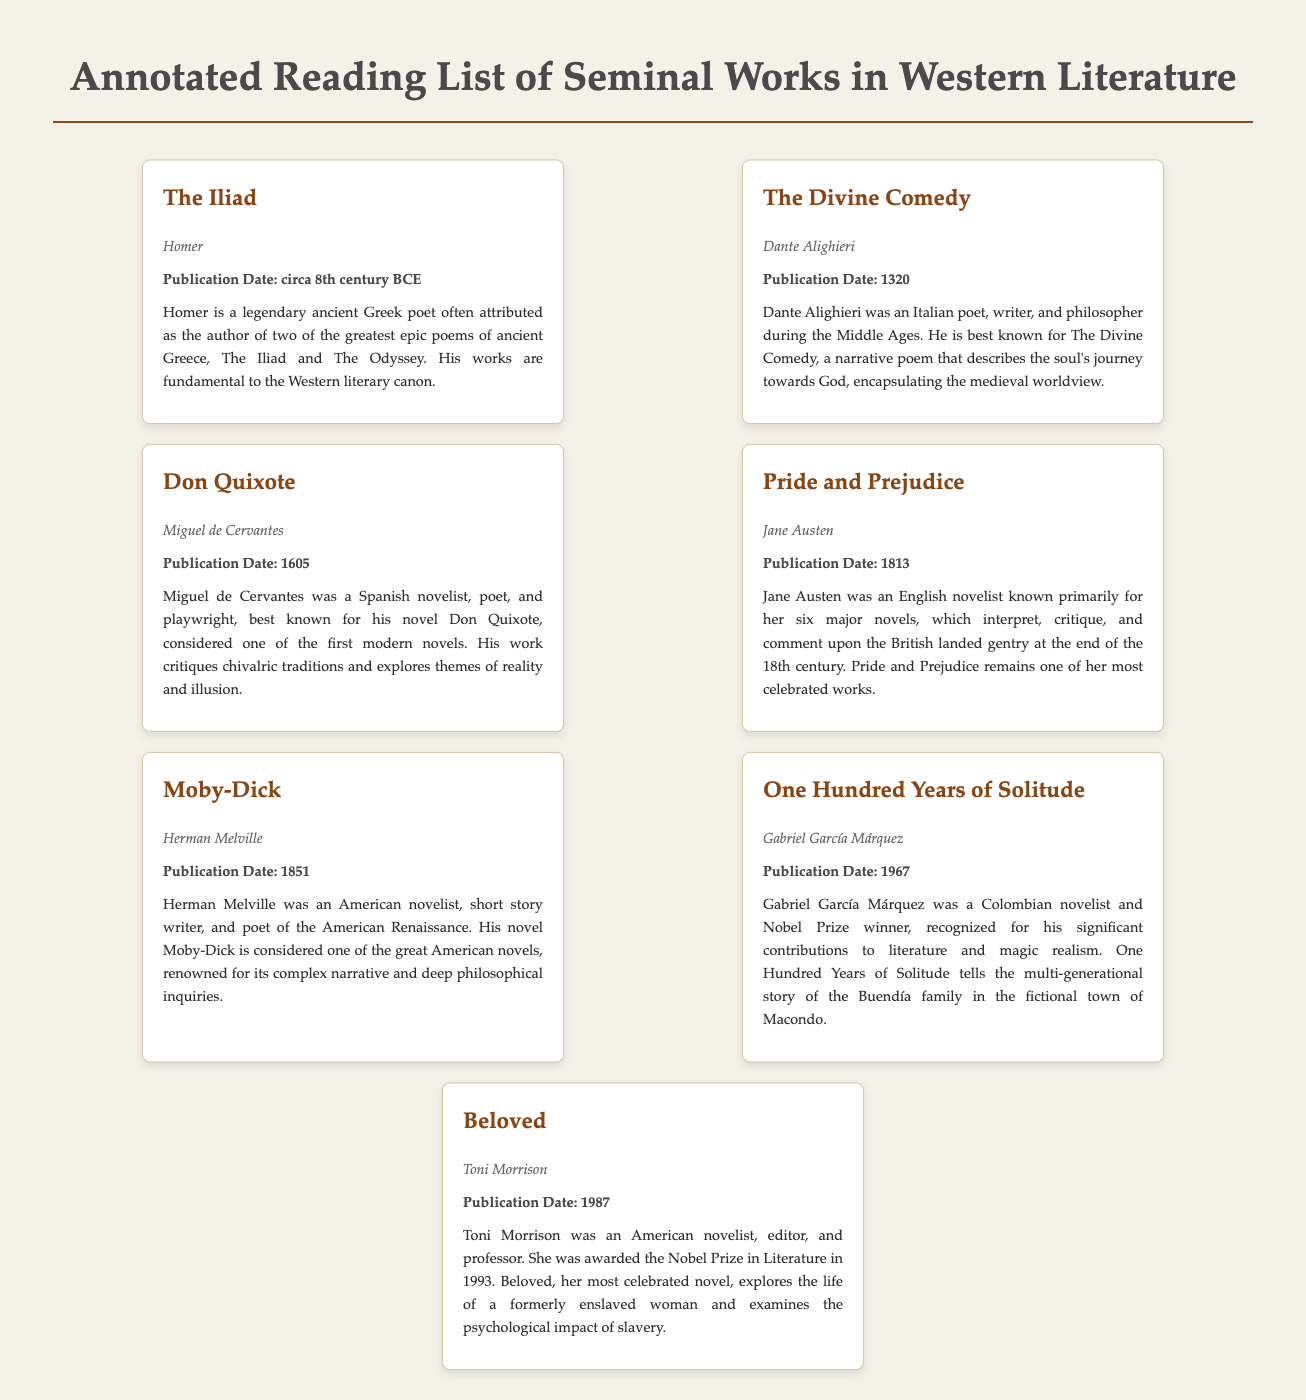What is the title of the first book listed? The first book listed in the document is presented as "The Iliad".
Answer: The Iliad Who is the author of "Don Quixote"? The author of "Don Quixote" is specified as Miguel de Cervantes.
Answer: Miguel de Cervantes What year was "Pride and Prejudice" published? The document states that "Pride and Prejudice" was published in the year 1813.
Answer: 1813 Which author won the Nobel Prize in Literature in 1993? The document attributes the Nobel Prize in Literature in 1993 to the author Toni Morrison.
Answer: Toni Morrison What is the publication date of "One Hundred Years of Solitude"? The publication date for "One Hundred Years of Solitude" is noted as 1967.
Answer: 1967 Which book is associated with the theme of a journey towards God? The document identifies "The Divine Comedy" as encapsulating the theme of a journey towards God.
Answer: The Divine Comedy How is Homer described in the authorial background section? Homer is described as a legendary ancient Greek poet often attributed as the author of two of the greatest epic poems.
Answer: Legendary ancient Greek poet What literary form is "Moby-Dick" regarded as? "Moby-Dick" is regarded as one of the great American novels in the document.
Answer: Great American novels What type of literary genre does Gabriel García Márquez's work represent? The document describes Gabriel García Márquez's work as representing magic realism.
Answer: Magic realism 